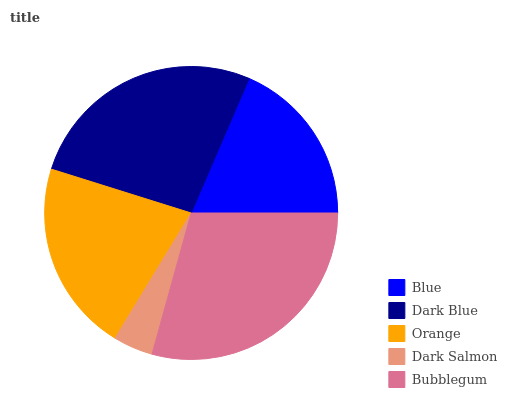Is Dark Salmon the minimum?
Answer yes or no. Yes. Is Bubblegum the maximum?
Answer yes or no. Yes. Is Dark Blue the minimum?
Answer yes or no. No. Is Dark Blue the maximum?
Answer yes or no. No. Is Dark Blue greater than Blue?
Answer yes or no. Yes. Is Blue less than Dark Blue?
Answer yes or no. Yes. Is Blue greater than Dark Blue?
Answer yes or no. No. Is Dark Blue less than Blue?
Answer yes or no. No. Is Orange the high median?
Answer yes or no. Yes. Is Orange the low median?
Answer yes or no. Yes. Is Blue the high median?
Answer yes or no. No. Is Dark Salmon the low median?
Answer yes or no. No. 